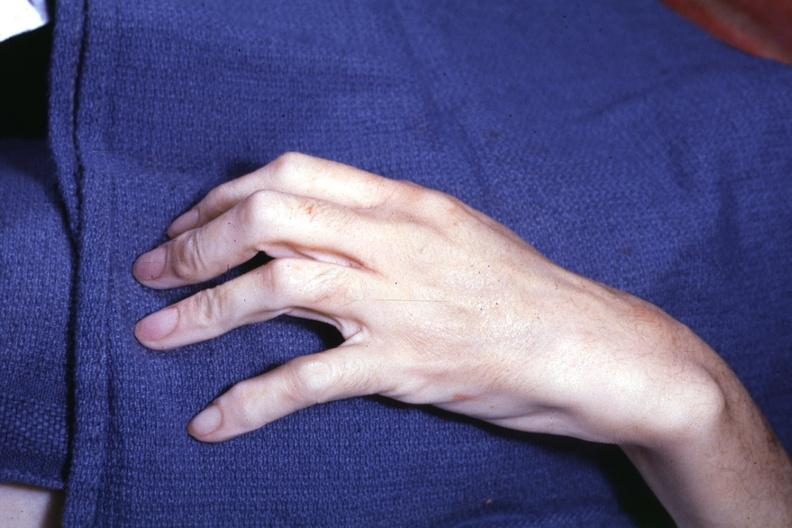does cortical nodule show long fingers interesting case see other slides?
Answer the question using a single word or phrase. No 